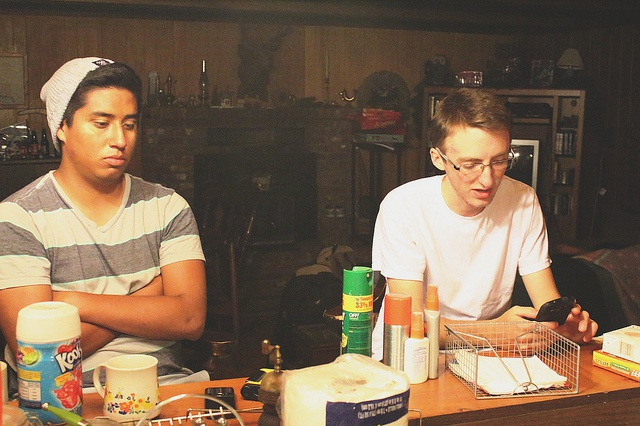Describe the objects in this image and their specific colors. I can see people in black, beige, orange, tan, and brown tones, people in black, ivory, and tan tones, couch in black, maroon, and gray tones, cup in black, khaki, and tan tones, and bottle in black, green, khaki, and darkgreen tones in this image. 